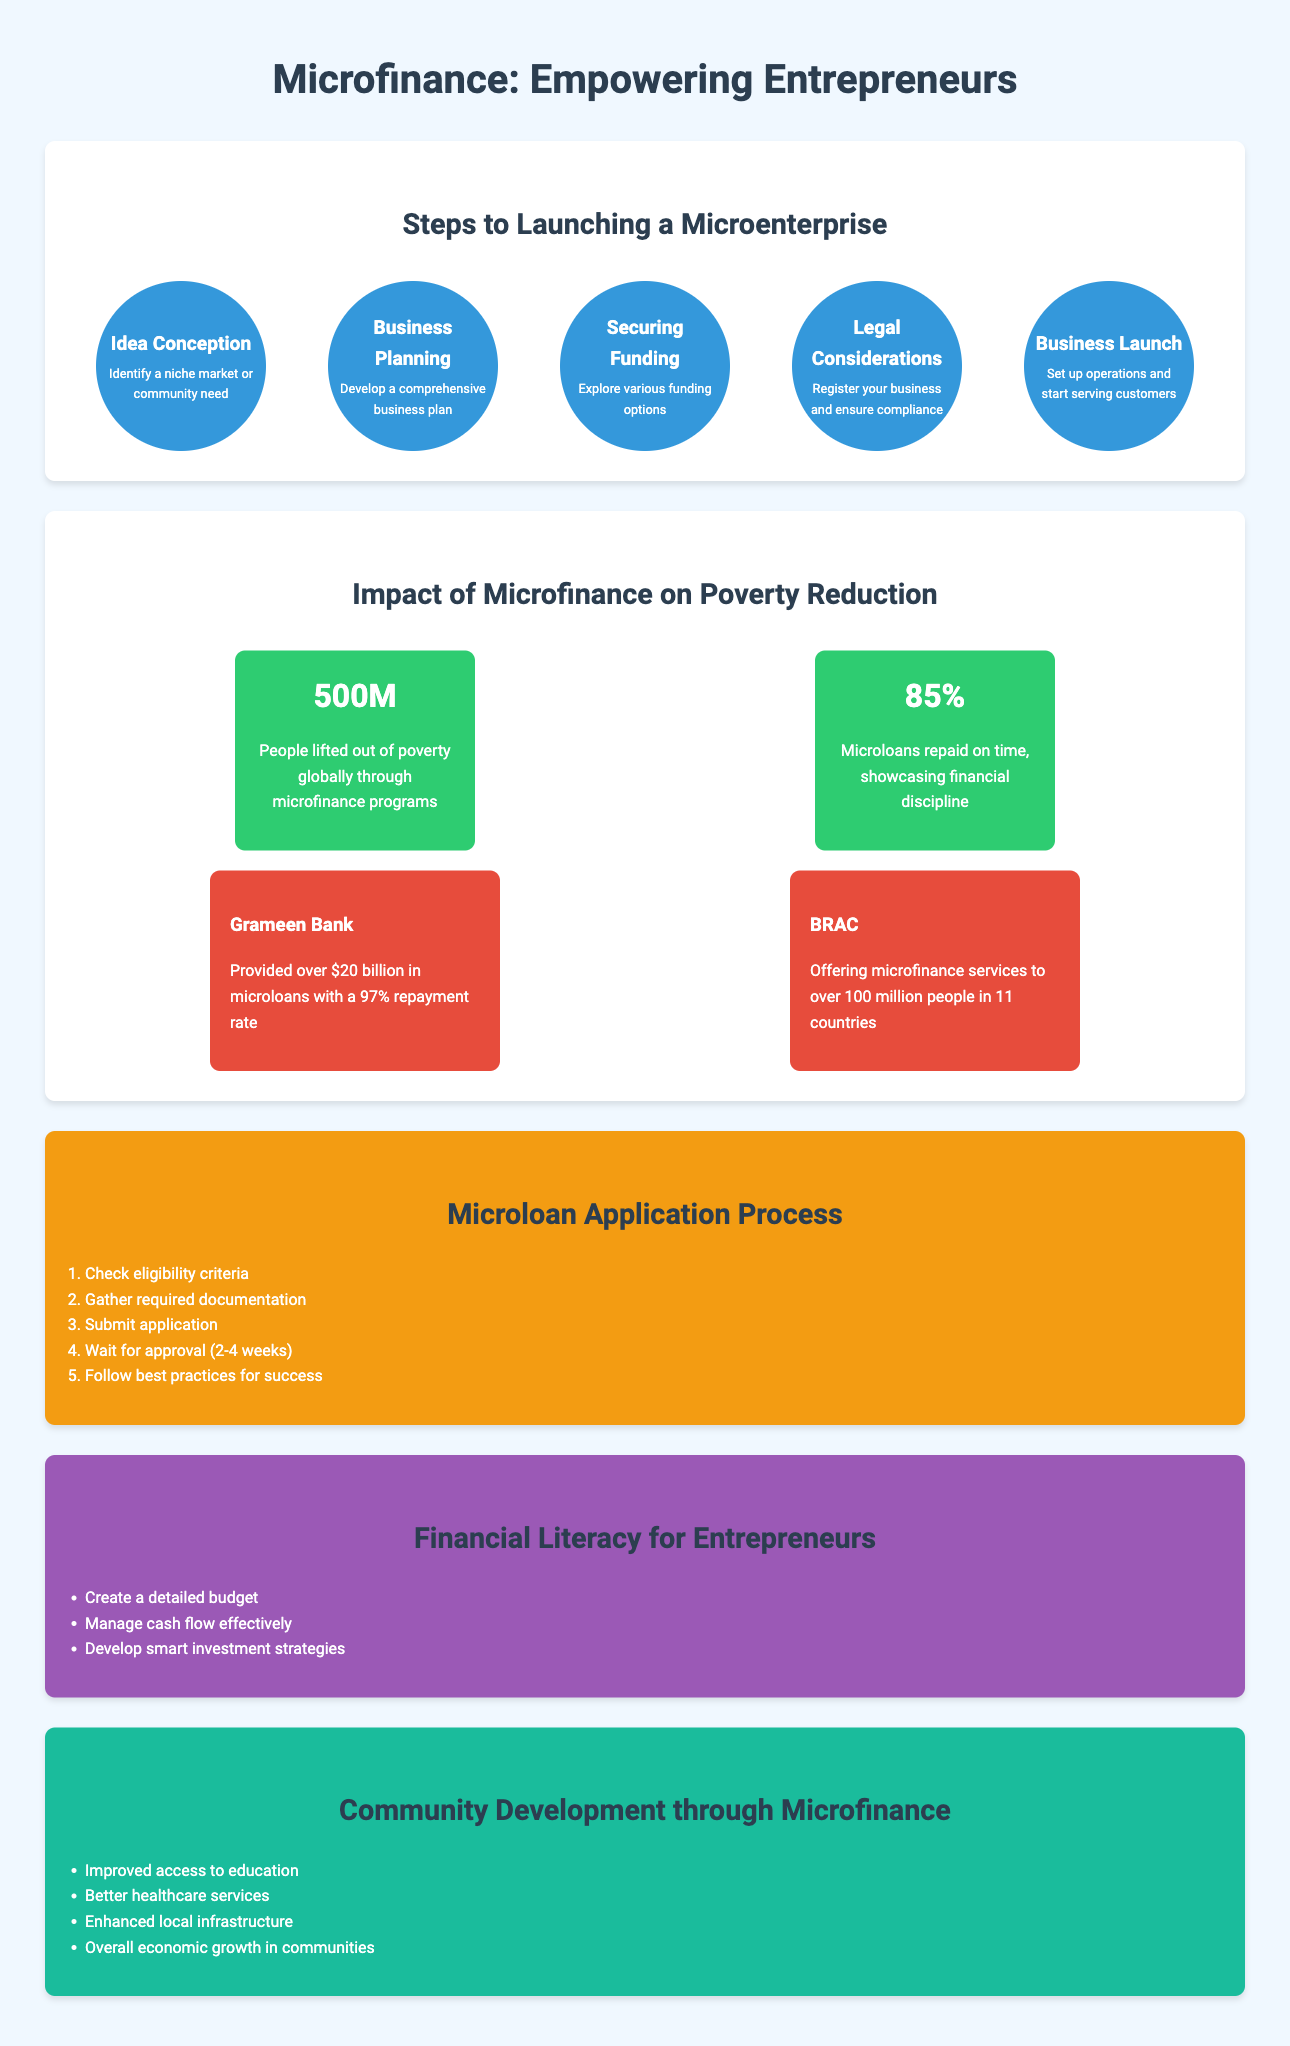what is the first step in launching a microenterprise? The first step in launching a microenterprise is Idea Conception, where one identifies a niche market or community need.
Answer: Idea Conception how many people have been lifted out of poverty through microfinance programs? The document states that 500 million people have been lifted out of poverty globally through microfinance programs.
Answer: 500M what percentage of microloans are repaid on time? According to the infographic, 85% of microloans are repaid on time.
Answer: 85% what is the average wait time for microloan approval? The document mentions that the approval timeline for a microloan is 2-4 weeks.
Answer: 2-4 weeks which organization provided over $20 billion in microloans? The case study highlights Grameen Bank as the organization that provided over $20 billion in microloans.
Answer: Grameen Bank what are two financial skills essential for entrepreneurs? The infographic lists budgeting and cash flow management as two essential financial skills for entrepreneurs.
Answer: budgeting, cash flow management what is a benefit of microfinance for community development? The document states that microfinance leads to improved access to education as one of its benefits for community development.
Answer: Improved access to education which color represents the section on community impact in the infographic? The section on community impact is represented in a background color of #1abc9c.
Answer: #1abc9c how many case studies are mentioned in the document? The infographic mentions two case studies: Grameen Bank and BRAC.
Answer: 2 